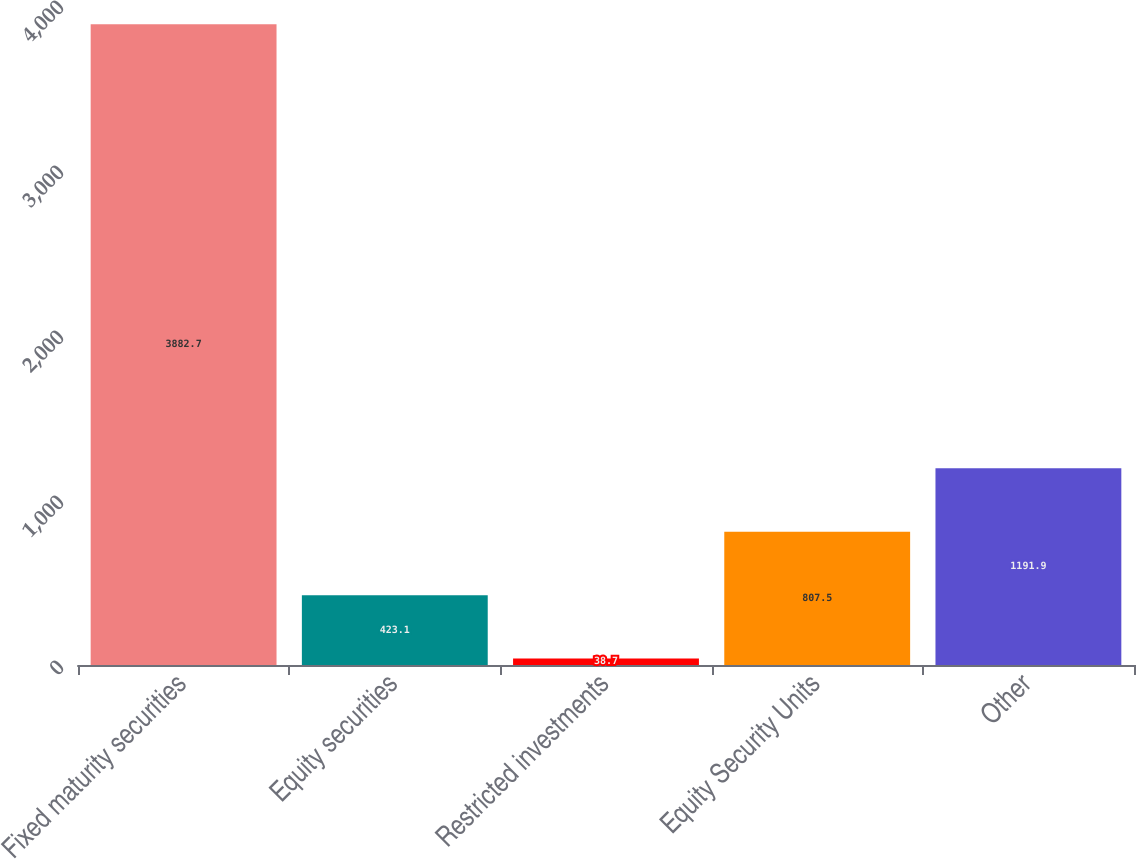<chart> <loc_0><loc_0><loc_500><loc_500><bar_chart><fcel>Fixed maturity securities<fcel>Equity securities<fcel>Restricted investments<fcel>Equity Security Units<fcel>Other<nl><fcel>3882.7<fcel>423.1<fcel>38.7<fcel>807.5<fcel>1191.9<nl></chart> 